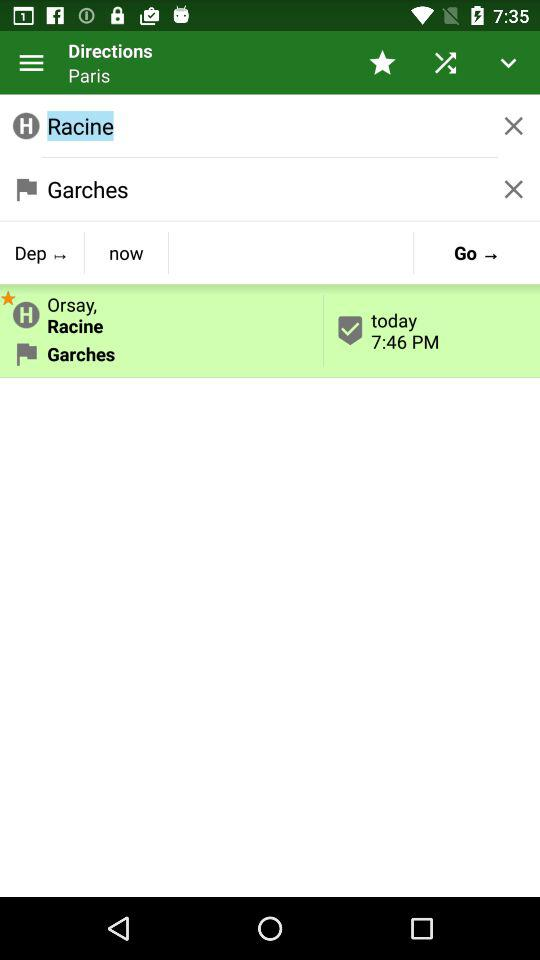What is the name of the destination station? The destination station is "Garches". 